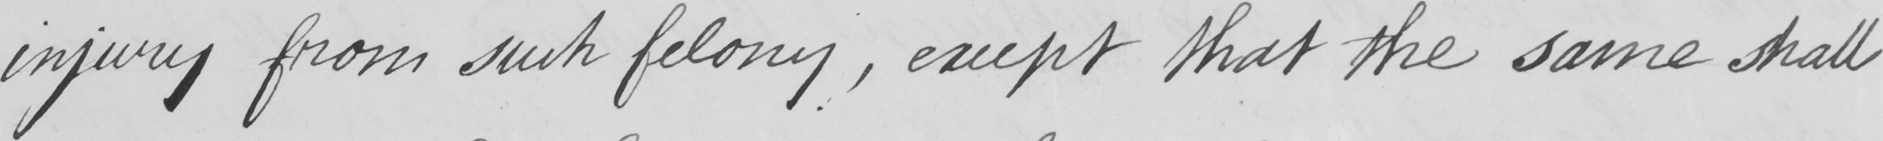Transcribe the text shown in this historical manuscript line. injury from such felony , except that the same shall 